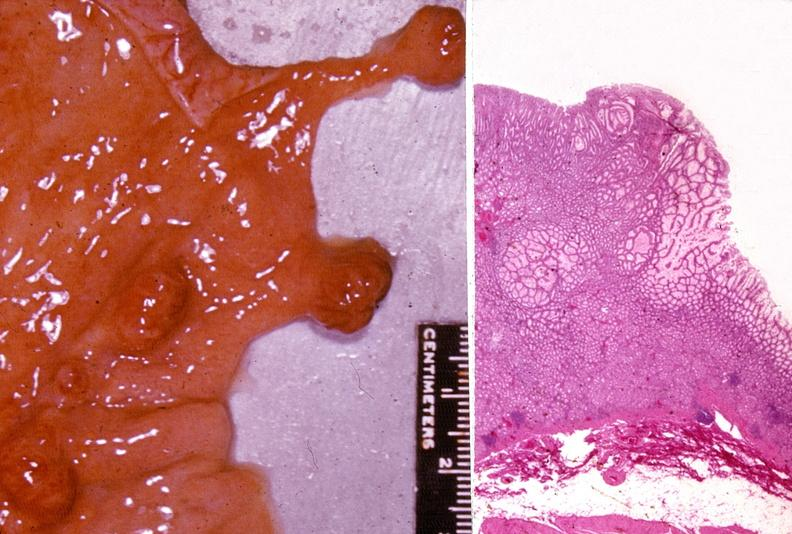what does this image show?
Answer the question using a single word or phrase. Stomach 